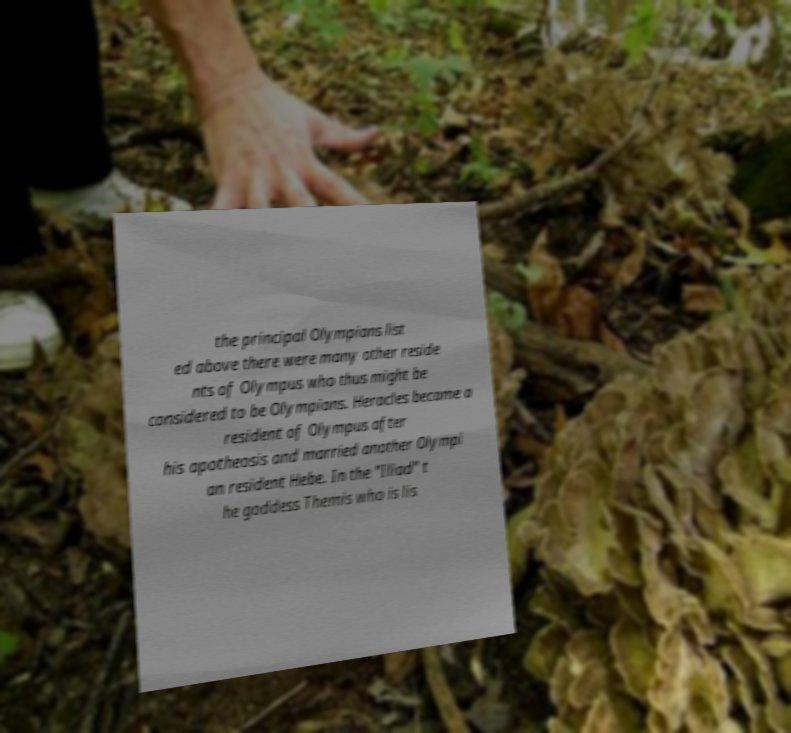Can you accurately transcribe the text from the provided image for me? the principal Olympians list ed above there were many other reside nts of Olympus who thus might be considered to be Olympians. Heracles became a resident of Olympus after his apotheosis and married another Olympi an resident Hebe. In the "Iliad" t he goddess Themis who is lis 